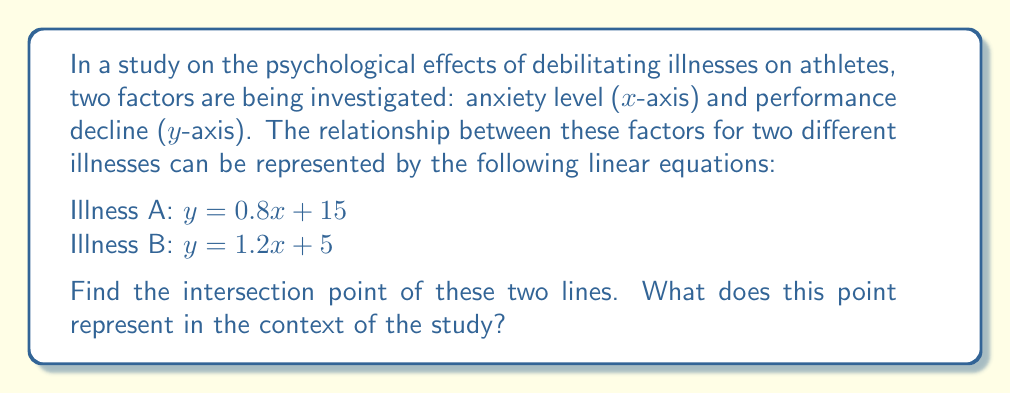Teach me how to tackle this problem. To find the intersection point of these two lines, we need to solve the system of equations:

$$\begin{cases}
y = 0.8x + 15 \\
y = 1.2x + 5
\end{cases}$$

1) Since both equations are equal to y, we can set them equal to each other:

   $0.8x + 15 = 1.2x + 5$

2) Subtract 0.8x from both sides:

   $15 = 0.4x + 5$

3) Subtract 5 from both sides:

   $10 = 0.4x$

4) Divide both sides by 0.4:

   $x = 25$

5) Now that we know x, we can substitute it into either of the original equations to find y. Let's use the equation for Illness A:

   $y = 0.8(25) + 15$
   $y = 20 + 15 = 35$

Therefore, the intersection point is (25, 35).

In the context of the study, this point represents the level of anxiety (25) and performance decline (35) at which both illnesses have the same psychological impact on athletes. At anxiety levels below 25, Illness A has a greater impact on performance decline, while at anxiety levels above 25, Illness B has a greater impact.
Answer: The intersection point is (25, 35). This represents an anxiety level of 25 and a performance decline of 35, where both illnesses have the same psychological impact on athletes. 